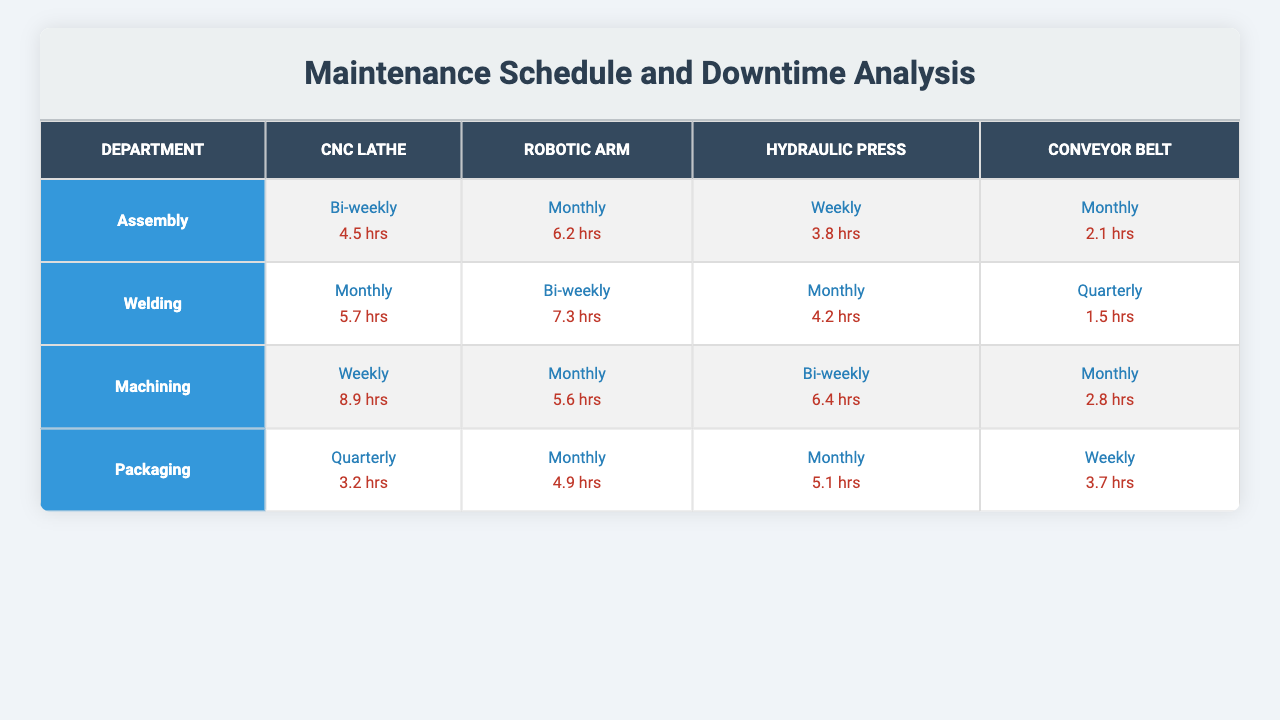What is the maintenance schedule for the CNC Lathe in the Assembly department? The table shows that the maintenance schedule for the CNC Lathe in the Assembly department is bi-weekly.
Answer: Bi-weekly Which machine experiences the most downtime in the Machining department? In the Machining department, the CNC Lathe has the highest downtime of 8.9 hours, compared to other machines listed.
Answer: CNC Lathe What is the total downtime for all machines in the Packaging department? Adding the downtime for each machine in the Packaging department: 3.2 (CNC Lathe) + 4.9 (Robotic Arm) + 5.1 (Hydraulic Press) + 3.7 (Conveyor Belt) = 16.9 hours.
Answer: 16.9 hours Does the Robotic Arm in the Welding department have a higher downtime than the Hydraulic Press? The downtime for the Robotic Arm is 7.3 hours, while the Hydraulic Press has 4.2 hours; thus, the Robotic Arm has higher downtime.
Answer: Yes If the maintenance schedule for Conveyor Belt in Machining was changed to bi-weekly, how would the total downtime across all departments change? The current downtime for the Conveyor Belt in Machining is 2.8 hours for a monthly schedule. If changed to bi-weekly, it would double to approximately 5.6 hours, increasing the total downtime by 2.8 hours. The previous total downtime was 16.9 hours in Packaging + 12.6 in Machining (2.8 for Conveyor, 5.6 for Robotic, 6.4 for Hydraulic) + 19.0 hours in Welding + 12.6 hours in Assembly = 61.1 hours. New total would be 61.1 + 2.8 = 63.9 hours.
Answer: 63.9 hours What is the average downtime for the Hydraulic Press across all departments? The downtimes for the Hydraulic Press are: 3.8 (Assembly), 4.2 (Welding), 6.4 (Machining), and 5.1 (Packaging). The total is 19.5 hours and dividing by 4 departments gives an average of 4.875 hours.
Answer: 4.875 hours In which department does the Conveyor Belt have the least downtime? In the table, the Conveyor Belt has 2.1 hours of downtime in the Assembly department, which is lower than its downtime in the other departments.
Answer: Assembly How many machines have a maintenance schedule of Monthly across all departments? The machines with a monthly schedule are the Robotic Arm in Assembly, CNC Lathe and Hydraulic Press in Welding, Robotic Arm and Conveyor in Machining, and all three machines in Packaging. Counting gives a total of 6.
Answer: 6 machines Which department has the lowest total downtime and how much is it? Adding the downtimes for each machine in Assembly gives 4.5 (CNC Lathe) + 6.2 (Robotic Arm) + 3.8 (Hydraulic Press) + 2.1 (Conveyor Belt) = 16.6 hours, which is lower compared to other departments.
Answer: Assembly; 16.6 hours 